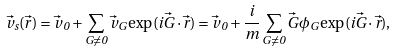Convert formula to latex. <formula><loc_0><loc_0><loc_500><loc_500>\vec { v } _ { s } ( \vec { r } ) = \vec { v } _ { \, 0 } + \sum _ { G \ne 0 } \vec { v } _ { G } \exp ( i \vec { G } \cdot \vec { r } ) = \vec { v } _ { \, 0 } + \frac { i } { m } \sum _ { G \ne 0 } \vec { G } \phi _ { G } \exp ( i \vec { G } \cdot \vec { r } ) ,</formula> 